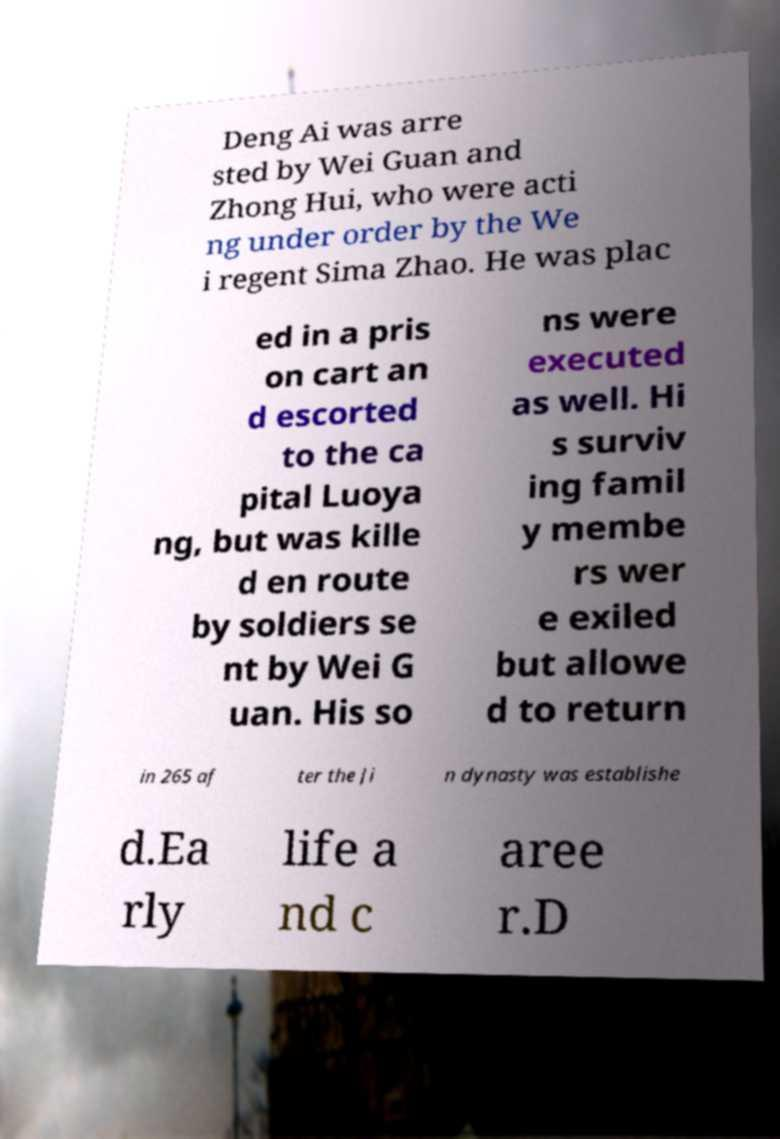For documentation purposes, I need the text within this image transcribed. Could you provide that? Deng Ai was arre sted by Wei Guan and Zhong Hui, who were acti ng under order by the We i regent Sima Zhao. He was plac ed in a pris on cart an d escorted to the ca pital Luoya ng, but was kille d en route by soldiers se nt by Wei G uan. His so ns were executed as well. Hi s surviv ing famil y membe rs wer e exiled but allowe d to return in 265 af ter the Ji n dynasty was establishe d.Ea rly life a nd c aree r.D 